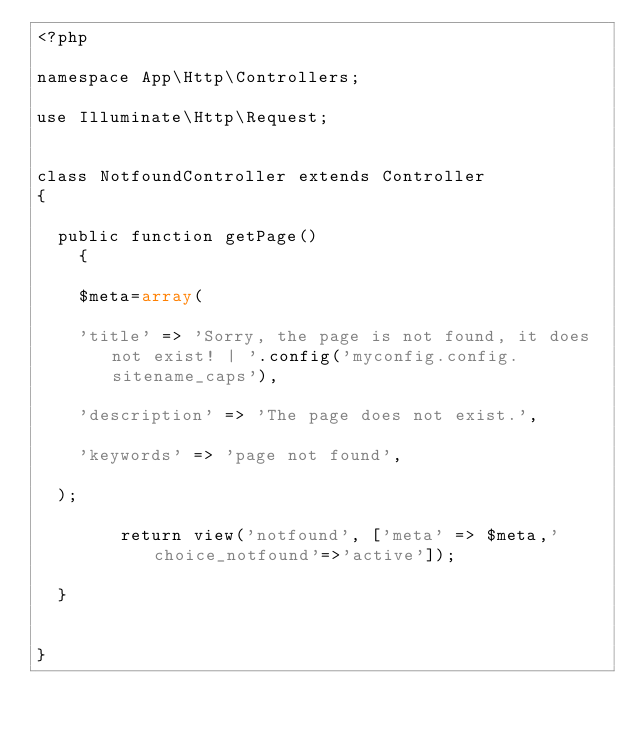<code> <loc_0><loc_0><loc_500><loc_500><_PHP_><?php

namespace App\Http\Controllers;

use Illuminate\Http\Request;


class NotfoundController extends Controller
{
	
	public function getPage()
    {
		
		$meta=array(

		'title' => 'Sorry, the page is not found, it does not exist! | '.config('myconfig.config.sitename_caps'),

		'description' => 'The page does not exist.',

		'keywords' => 'page not found',

	);
		
        return view('notfound', ['meta' => $meta,'choice_notfound'=>'active']);
		
	}
	
	
}
</code> 